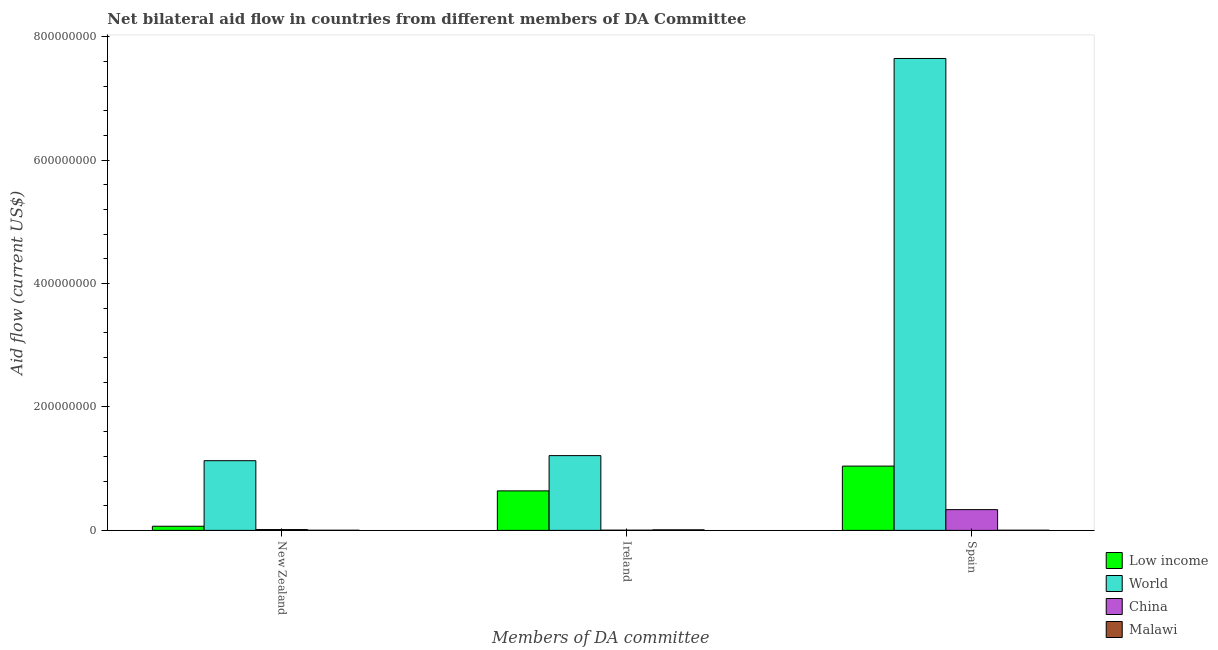Are the number of bars on each tick of the X-axis equal?
Provide a succinct answer. Yes. What is the amount of aid provided by new zealand in China?
Your answer should be compact. 1.35e+06. Across all countries, what is the maximum amount of aid provided by ireland?
Ensure brevity in your answer.  1.21e+08. Across all countries, what is the minimum amount of aid provided by ireland?
Give a very brief answer. 3.70e+05. In which country was the amount of aid provided by spain maximum?
Offer a very short reply. World. In which country was the amount of aid provided by spain minimum?
Your answer should be very brief. Malawi. What is the total amount of aid provided by spain in the graph?
Give a very brief answer. 9.03e+08. What is the difference between the amount of aid provided by new zealand in Malawi and that in China?
Make the answer very short. -1.10e+06. What is the difference between the amount of aid provided by spain in World and the amount of aid provided by new zealand in Malawi?
Your response must be concise. 7.64e+08. What is the average amount of aid provided by ireland per country?
Your answer should be very brief. 4.66e+07. What is the difference between the amount of aid provided by new zealand and amount of aid provided by spain in Low income?
Offer a very short reply. -9.74e+07. In how many countries, is the amount of aid provided by new zealand greater than 160000000 US$?
Provide a succinct answer. 0. What is the ratio of the amount of aid provided by new zealand in Malawi to that in China?
Provide a succinct answer. 0.19. Is the amount of aid provided by new zealand in Low income less than that in Malawi?
Your answer should be very brief. No. Is the difference between the amount of aid provided by new zealand in Low income and China greater than the difference between the amount of aid provided by ireland in Low income and China?
Offer a terse response. No. What is the difference between the highest and the second highest amount of aid provided by new zealand?
Make the answer very short. 1.06e+08. What is the difference between the highest and the lowest amount of aid provided by ireland?
Offer a very short reply. 1.21e+08. In how many countries, is the amount of aid provided by new zealand greater than the average amount of aid provided by new zealand taken over all countries?
Offer a very short reply. 1. Is the sum of the amount of aid provided by ireland in China and World greater than the maximum amount of aid provided by spain across all countries?
Ensure brevity in your answer.  No. What does the 4th bar from the left in New Zealand represents?
Your response must be concise. Malawi. What does the 4th bar from the right in New Zealand represents?
Make the answer very short. Low income. How many bars are there?
Make the answer very short. 12. How many countries are there in the graph?
Your answer should be very brief. 4. What is the title of the graph?
Ensure brevity in your answer.  Net bilateral aid flow in countries from different members of DA Committee. Does "Timor-Leste" appear as one of the legend labels in the graph?
Your answer should be very brief. No. What is the label or title of the X-axis?
Provide a short and direct response. Members of DA committee. What is the Aid flow (current US$) in Low income in New Zealand?
Your answer should be very brief. 6.73e+06. What is the Aid flow (current US$) in World in New Zealand?
Offer a very short reply. 1.13e+08. What is the Aid flow (current US$) in China in New Zealand?
Offer a terse response. 1.35e+06. What is the Aid flow (current US$) of Malawi in New Zealand?
Keep it short and to the point. 2.50e+05. What is the Aid flow (current US$) of Low income in Ireland?
Provide a succinct answer. 6.40e+07. What is the Aid flow (current US$) of World in Ireland?
Keep it short and to the point. 1.21e+08. What is the Aid flow (current US$) of China in Ireland?
Make the answer very short. 3.70e+05. What is the Aid flow (current US$) in Malawi in Ireland?
Your answer should be very brief. 9.40e+05. What is the Aid flow (current US$) in Low income in Spain?
Give a very brief answer. 1.04e+08. What is the Aid flow (current US$) in World in Spain?
Your answer should be very brief. 7.65e+08. What is the Aid flow (current US$) of China in Spain?
Provide a succinct answer. 3.36e+07. What is the Aid flow (current US$) in Malawi in Spain?
Provide a succinct answer. 2.60e+05. Across all Members of DA committee, what is the maximum Aid flow (current US$) of Low income?
Keep it short and to the point. 1.04e+08. Across all Members of DA committee, what is the maximum Aid flow (current US$) of World?
Your answer should be very brief. 7.65e+08. Across all Members of DA committee, what is the maximum Aid flow (current US$) in China?
Provide a short and direct response. 3.36e+07. Across all Members of DA committee, what is the maximum Aid flow (current US$) of Malawi?
Your response must be concise. 9.40e+05. Across all Members of DA committee, what is the minimum Aid flow (current US$) of Low income?
Your answer should be compact. 6.73e+06. Across all Members of DA committee, what is the minimum Aid flow (current US$) in World?
Offer a terse response. 1.13e+08. Across all Members of DA committee, what is the minimum Aid flow (current US$) of China?
Make the answer very short. 3.70e+05. What is the total Aid flow (current US$) of Low income in the graph?
Offer a very short reply. 1.75e+08. What is the total Aid flow (current US$) in World in the graph?
Your answer should be compact. 9.99e+08. What is the total Aid flow (current US$) of China in the graph?
Your answer should be very brief. 3.54e+07. What is the total Aid flow (current US$) in Malawi in the graph?
Your answer should be very brief. 1.45e+06. What is the difference between the Aid flow (current US$) of Low income in New Zealand and that in Ireland?
Provide a succinct answer. -5.73e+07. What is the difference between the Aid flow (current US$) in World in New Zealand and that in Ireland?
Provide a succinct answer. -8.22e+06. What is the difference between the Aid flow (current US$) of China in New Zealand and that in Ireland?
Offer a very short reply. 9.80e+05. What is the difference between the Aid flow (current US$) of Malawi in New Zealand and that in Ireland?
Give a very brief answer. -6.90e+05. What is the difference between the Aid flow (current US$) of Low income in New Zealand and that in Spain?
Provide a short and direct response. -9.74e+07. What is the difference between the Aid flow (current US$) in World in New Zealand and that in Spain?
Offer a very short reply. -6.52e+08. What is the difference between the Aid flow (current US$) of China in New Zealand and that in Spain?
Offer a very short reply. -3.23e+07. What is the difference between the Aid flow (current US$) in Low income in Ireland and that in Spain?
Give a very brief answer. -4.02e+07. What is the difference between the Aid flow (current US$) of World in Ireland and that in Spain?
Offer a very short reply. -6.44e+08. What is the difference between the Aid flow (current US$) in China in Ireland and that in Spain?
Keep it short and to the point. -3.33e+07. What is the difference between the Aid flow (current US$) of Malawi in Ireland and that in Spain?
Your answer should be very brief. 6.80e+05. What is the difference between the Aid flow (current US$) of Low income in New Zealand and the Aid flow (current US$) of World in Ireland?
Make the answer very short. -1.14e+08. What is the difference between the Aid flow (current US$) in Low income in New Zealand and the Aid flow (current US$) in China in Ireland?
Your response must be concise. 6.36e+06. What is the difference between the Aid flow (current US$) of Low income in New Zealand and the Aid flow (current US$) of Malawi in Ireland?
Keep it short and to the point. 5.79e+06. What is the difference between the Aid flow (current US$) of World in New Zealand and the Aid flow (current US$) of China in Ireland?
Offer a terse response. 1.13e+08. What is the difference between the Aid flow (current US$) of World in New Zealand and the Aid flow (current US$) of Malawi in Ireland?
Provide a short and direct response. 1.12e+08. What is the difference between the Aid flow (current US$) in China in New Zealand and the Aid flow (current US$) in Malawi in Ireland?
Ensure brevity in your answer.  4.10e+05. What is the difference between the Aid flow (current US$) in Low income in New Zealand and the Aid flow (current US$) in World in Spain?
Your answer should be very brief. -7.58e+08. What is the difference between the Aid flow (current US$) in Low income in New Zealand and the Aid flow (current US$) in China in Spain?
Ensure brevity in your answer.  -2.69e+07. What is the difference between the Aid flow (current US$) in Low income in New Zealand and the Aid flow (current US$) in Malawi in Spain?
Your answer should be very brief. 6.47e+06. What is the difference between the Aid flow (current US$) of World in New Zealand and the Aid flow (current US$) of China in Spain?
Ensure brevity in your answer.  7.93e+07. What is the difference between the Aid flow (current US$) in World in New Zealand and the Aid flow (current US$) in Malawi in Spain?
Give a very brief answer. 1.13e+08. What is the difference between the Aid flow (current US$) in China in New Zealand and the Aid flow (current US$) in Malawi in Spain?
Provide a succinct answer. 1.09e+06. What is the difference between the Aid flow (current US$) in Low income in Ireland and the Aid flow (current US$) in World in Spain?
Keep it short and to the point. -7.01e+08. What is the difference between the Aid flow (current US$) of Low income in Ireland and the Aid flow (current US$) of China in Spain?
Provide a succinct answer. 3.04e+07. What is the difference between the Aid flow (current US$) of Low income in Ireland and the Aid flow (current US$) of Malawi in Spain?
Provide a short and direct response. 6.38e+07. What is the difference between the Aid flow (current US$) in World in Ireland and the Aid flow (current US$) in China in Spain?
Keep it short and to the point. 8.75e+07. What is the difference between the Aid flow (current US$) of World in Ireland and the Aid flow (current US$) of Malawi in Spain?
Offer a very short reply. 1.21e+08. What is the average Aid flow (current US$) in Low income per Members of DA committee?
Give a very brief answer. 5.83e+07. What is the average Aid flow (current US$) in World per Members of DA committee?
Ensure brevity in your answer.  3.33e+08. What is the average Aid flow (current US$) of China per Members of DA committee?
Make the answer very short. 1.18e+07. What is the average Aid flow (current US$) in Malawi per Members of DA committee?
Your answer should be compact. 4.83e+05. What is the difference between the Aid flow (current US$) of Low income and Aid flow (current US$) of World in New Zealand?
Your answer should be compact. -1.06e+08. What is the difference between the Aid flow (current US$) of Low income and Aid flow (current US$) of China in New Zealand?
Keep it short and to the point. 5.38e+06. What is the difference between the Aid flow (current US$) of Low income and Aid flow (current US$) of Malawi in New Zealand?
Ensure brevity in your answer.  6.48e+06. What is the difference between the Aid flow (current US$) of World and Aid flow (current US$) of China in New Zealand?
Give a very brief answer. 1.12e+08. What is the difference between the Aid flow (current US$) of World and Aid flow (current US$) of Malawi in New Zealand?
Offer a very short reply. 1.13e+08. What is the difference between the Aid flow (current US$) of China and Aid flow (current US$) of Malawi in New Zealand?
Ensure brevity in your answer.  1.10e+06. What is the difference between the Aid flow (current US$) in Low income and Aid flow (current US$) in World in Ireland?
Your answer should be compact. -5.72e+07. What is the difference between the Aid flow (current US$) of Low income and Aid flow (current US$) of China in Ireland?
Your answer should be very brief. 6.36e+07. What is the difference between the Aid flow (current US$) of Low income and Aid flow (current US$) of Malawi in Ireland?
Offer a very short reply. 6.31e+07. What is the difference between the Aid flow (current US$) in World and Aid flow (current US$) in China in Ireland?
Your answer should be compact. 1.21e+08. What is the difference between the Aid flow (current US$) of World and Aid flow (current US$) of Malawi in Ireland?
Your answer should be compact. 1.20e+08. What is the difference between the Aid flow (current US$) in China and Aid flow (current US$) in Malawi in Ireland?
Your answer should be compact. -5.70e+05. What is the difference between the Aid flow (current US$) of Low income and Aid flow (current US$) of World in Spain?
Your answer should be compact. -6.61e+08. What is the difference between the Aid flow (current US$) in Low income and Aid flow (current US$) in China in Spain?
Keep it short and to the point. 7.05e+07. What is the difference between the Aid flow (current US$) in Low income and Aid flow (current US$) in Malawi in Spain?
Offer a very short reply. 1.04e+08. What is the difference between the Aid flow (current US$) of World and Aid flow (current US$) of China in Spain?
Ensure brevity in your answer.  7.31e+08. What is the difference between the Aid flow (current US$) in World and Aid flow (current US$) in Malawi in Spain?
Offer a very short reply. 7.64e+08. What is the difference between the Aid flow (current US$) of China and Aid flow (current US$) of Malawi in Spain?
Offer a terse response. 3.34e+07. What is the ratio of the Aid flow (current US$) of Low income in New Zealand to that in Ireland?
Your answer should be very brief. 0.11. What is the ratio of the Aid flow (current US$) in World in New Zealand to that in Ireland?
Provide a short and direct response. 0.93. What is the ratio of the Aid flow (current US$) in China in New Zealand to that in Ireland?
Keep it short and to the point. 3.65. What is the ratio of the Aid flow (current US$) in Malawi in New Zealand to that in Ireland?
Give a very brief answer. 0.27. What is the ratio of the Aid flow (current US$) of Low income in New Zealand to that in Spain?
Offer a terse response. 0.06. What is the ratio of the Aid flow (current US$) of World in New Zealand to that in Spain?
Give a very brief answer. 0.15. What is the ratio of the Aid flow (current US$) of China in New Zealand to that in Spain?
Provide a short and direct response. 0.04. What is the ratio of the Aid flow (current US$) of Malawi in New Zealand to that in Spain?
Offer a terse response. 0.96. What is the ratio of the Aid flow (current US$) in Low income in Ireland to that in Spain?
Give a very brief answer. 0.61. What is the ratio of the Aid flow (current US$) of World in Ireland to that in Spain?
Give a very brief answer. 0.16. What is the ratio of the Aid flow (current US$) in China in Ireland to that in Spain?
Your answer should be compact. 0.01. What is the ratio of the Aid flow (current US$) of Malawi in Ireland to that in Spain?
Offer a very short reply. 3.62. What is the difference between the highest and the second highest Aid flow (current US$) in Low income?
Your answer should be compact. 4.02e+07. What is the difference between the highest and the second highest Aid flow (current US$) in World?
Provide a short and direct response. 6.44e+08. What is the difference between the highest and the second highest Aid flow (current US$) of China?
Ensure brevity in your answer.  3.23e+07. What is the difference between the highest and the second highest Aid flow (current US$) in Malawi?
Offer a very short reply. 6.80e+05. What is the difference between the highest and the lowest Aid flow (current US$) in Low income?
Provide a short and direct response. 9.74e+07. What is the difference between the highest and the lowest Aid flow (current US$) in World?
Keep it short and to the point. 6.52e+08. What is the difference between the highest and the lowest Aid flow (current US$) in China?
Your answer should be very brief. 3.33e+07. What is the difference between the highest and the lowest Aid flow (current US$) of Malawi?
Offer a very short reply. 6.90e+05. 